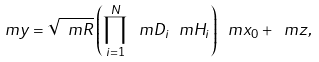Convert formula to latex. <formula><loc_0><loc_0><loc_500><loc_500>\ m y = \sqrt { \ m R } \left ( \prod _ { i = 1 } ^ { N } \ m D _ { i } \ m H _ { i } \right ) \ m x _ { 0 } + \ m z ,</formula> 